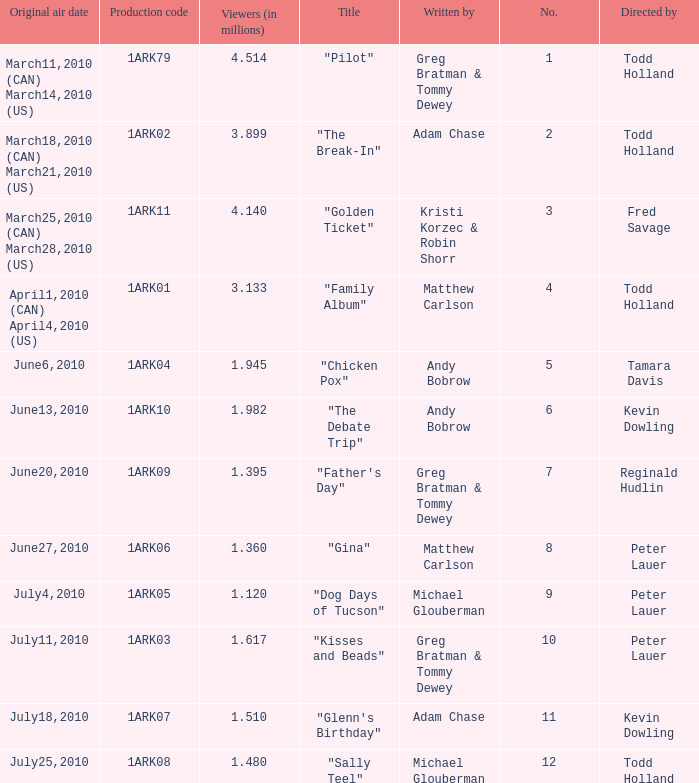How many millions of people viewed "Father's Day"? 1.395. 